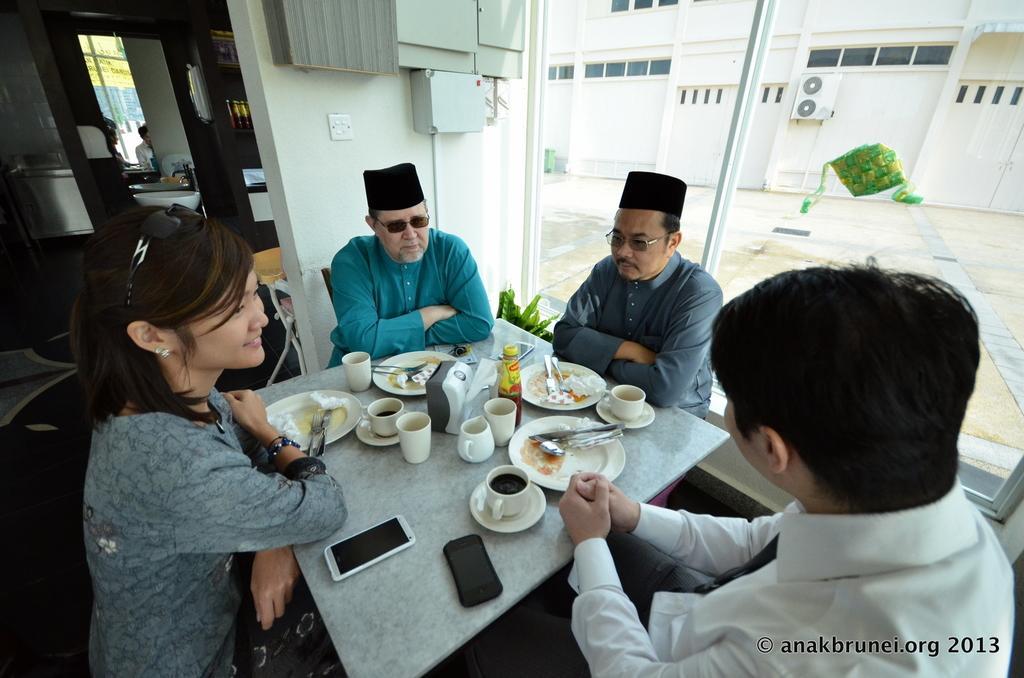Describe this image in one or two sentences. In this image I can see the group of people sitting in-front of the table. On the table there are plates,cups,bottle and the mobiles. To the right there is a window. Through the window I can see a building. 